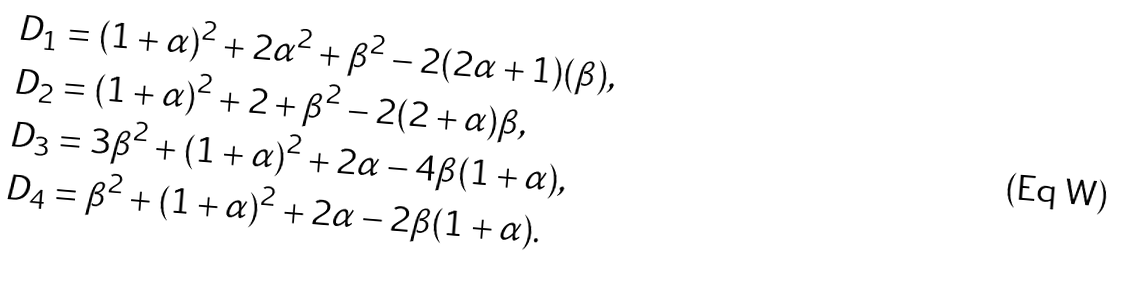<formula> <loc_0><loc_0><loc_500><loc_500>D _ { 1 } & = ( 1 + \alpha ) ^ { 2 } + 2 \alpha ^ { 2 } + \beta ^ { 2 } - 2 ( 2 \alpha + 1 ) ( \beta ) , \\ D _ { 2 } & = ( 1 + \alpha ) ^ { 2 } + 2 + \beta ^ { 2 } - 2 ( 2 + \alpha ) \beta , \\ D _ { 3 } & = 3 \beta ^ { 2 } + ( 1 + \alpha ) ^ { 2 } + 2 \alpha - 4 \beta ( 1 + \alpha ) , \\ D _ { 4 } & = \beta ^ { 2 } + ( 1 + \alpha ) ^ { 2 } + 2 \alpha - 2 \beta ( 1 + \alpha ) .</formula> 